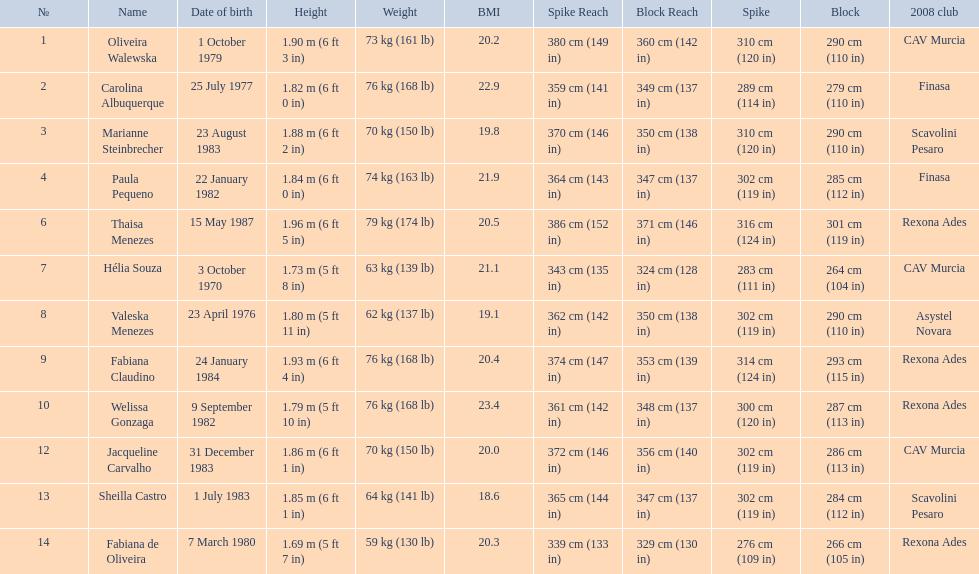Who played during the brazil at the 2008 summer olympics event? Oliveira Walewska, Carolina Albuquerque, Marianne Steinbrecher, Paula Pequeno, Thaisa Menezes, Hélia Souza, Valeska Menezes, Fabiana Claudino, Welissa Gonzaga, Jacqueline Carvalho, Sheilla Castro, Fabiana de Oliveira. And what was the recorded height of each player? 1.90 m (6 ft 3 in), 1.82 m (6 ft 0 in), 1.88 m (6 ft 2 in), 1.84 m (6 ft 0 in), 1.96 m (6 ft 5 in), 1.73 m (5 ft 8 in), 1.80 m (5 ft 11 in), 1.93 m (6 ft 4 in), 1.79 m (5 ft 10 in), 1.86 m (6 ft 1 in), 1.85 m (6 ft 1 in), 1.69 m (5 ft 7 in). Of those, which player is the shortest? Fabiana de Oliveira. 